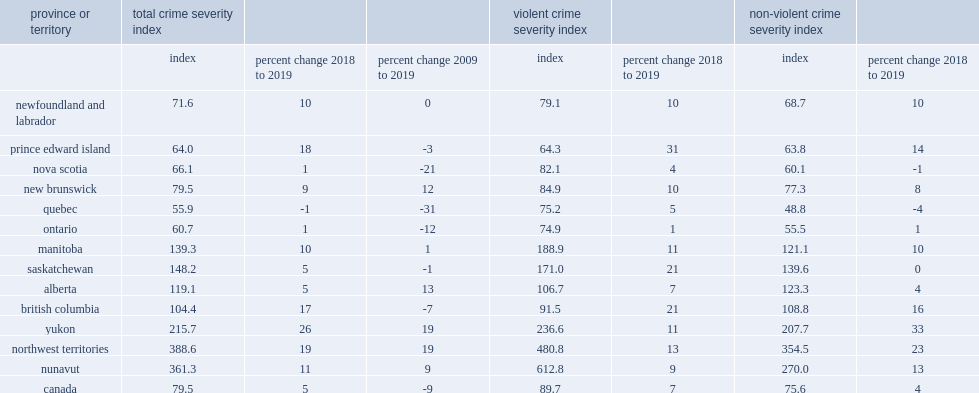Between 2018 and 2019, 12 of canada's 13 provinces and territories reported increases in their csi, which province reported a decrease in its csi? Quebec. 